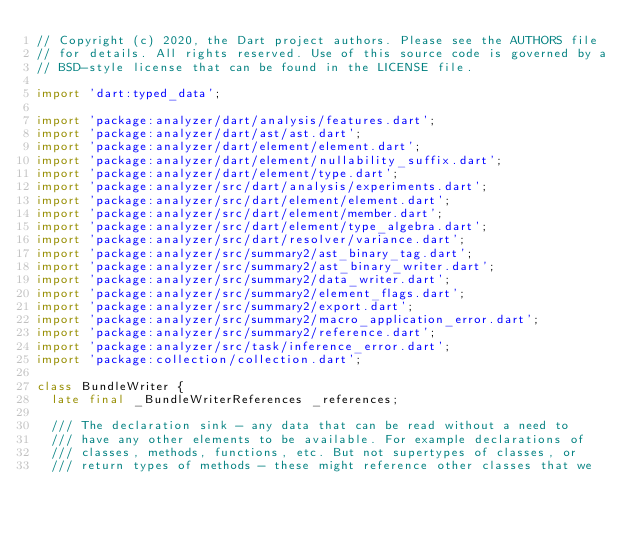Convert code to text. <code><loc_0><loc_0><loc_500><loc_500><_Dart_>// Copyright (c) 2020, the Dart project authors. Please see the AUTHORS file
// for details. All rights reserved. Use of this source code is governed by a
// BSD-style license that can be found in the LICENSE file.

import 'dart:typed_data';

import 'package:analyzer/dart/analysis/features.dart';
import 'package:analyzer/dart/ast/ast.dart';
import 'package:analyzer/dart/element/element.dart';
import 'package:analyzer/dart/element/nullability_suffix.dart';
import 'package:analyzer/dart/element/type.dart';
import 'package:analyzer/src/dart/analysis/experiments.dart';
import 'package:analyzer/src/dart/element/element.dart';
import 'package:analyzer/src/dart/element/member.dart';
import 'package:analyzer/src/dart/element/type_algebra.dart';
import 'package:analyzer/src/dart/resolver/variance.dart';
import 'package:analyzer/src/summary2/ast_binary_tag.dart';
import 'package:analyzer/src/summary2/ast_binary_writer.dart';
import 'package:analyzer/src/summary2/data_writer.dart';
import 'package:analyzer/src/summary2/element_flags.dart';
import 'package:analyzer/src/summary2/export.dart';
import 'package:analyzer/src/summary2/macro_application_error.dart';
import 'package:analyzer/src/summary2/reference.dart';
import 'package:analyzer/src/task/inference_error.dart';
import 'package:collection/collection.dart';

class BundleWriter {
  late final _BundleWriterReferences _references;

  /// The declaration sink - any data that can be read without a need to
  /// have any other elements to be available. For example declarations of
  /// classes, methods, functions, etc. But not supertypes of classes, or
  /// return types of methods - these might reference other classes that we</code> 